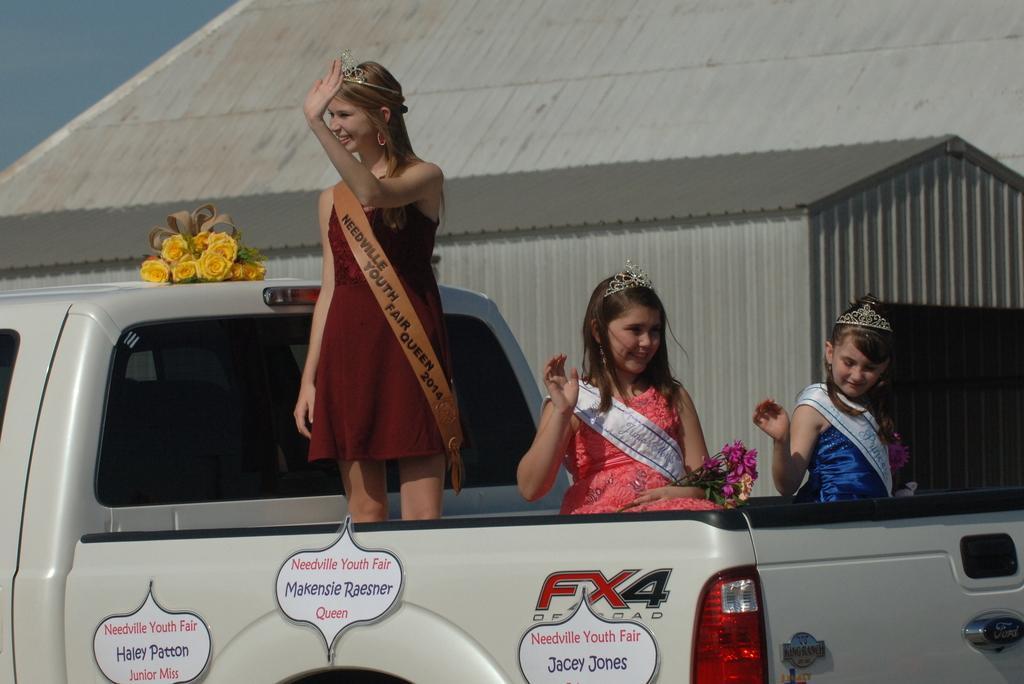How would you summarize this image in a sentence or two? In this picture I can see there is a truck and there are three girls, among them I can see a girl is standing, she is wearing a sash, crown, she is wearing a brown color dress and she is smiling. There are two other girls sitting and they are wearing sash and crowns. There are a few boards placed on the truck, they are holding flowers and there is a building in the backdrop, the sky is clear. 